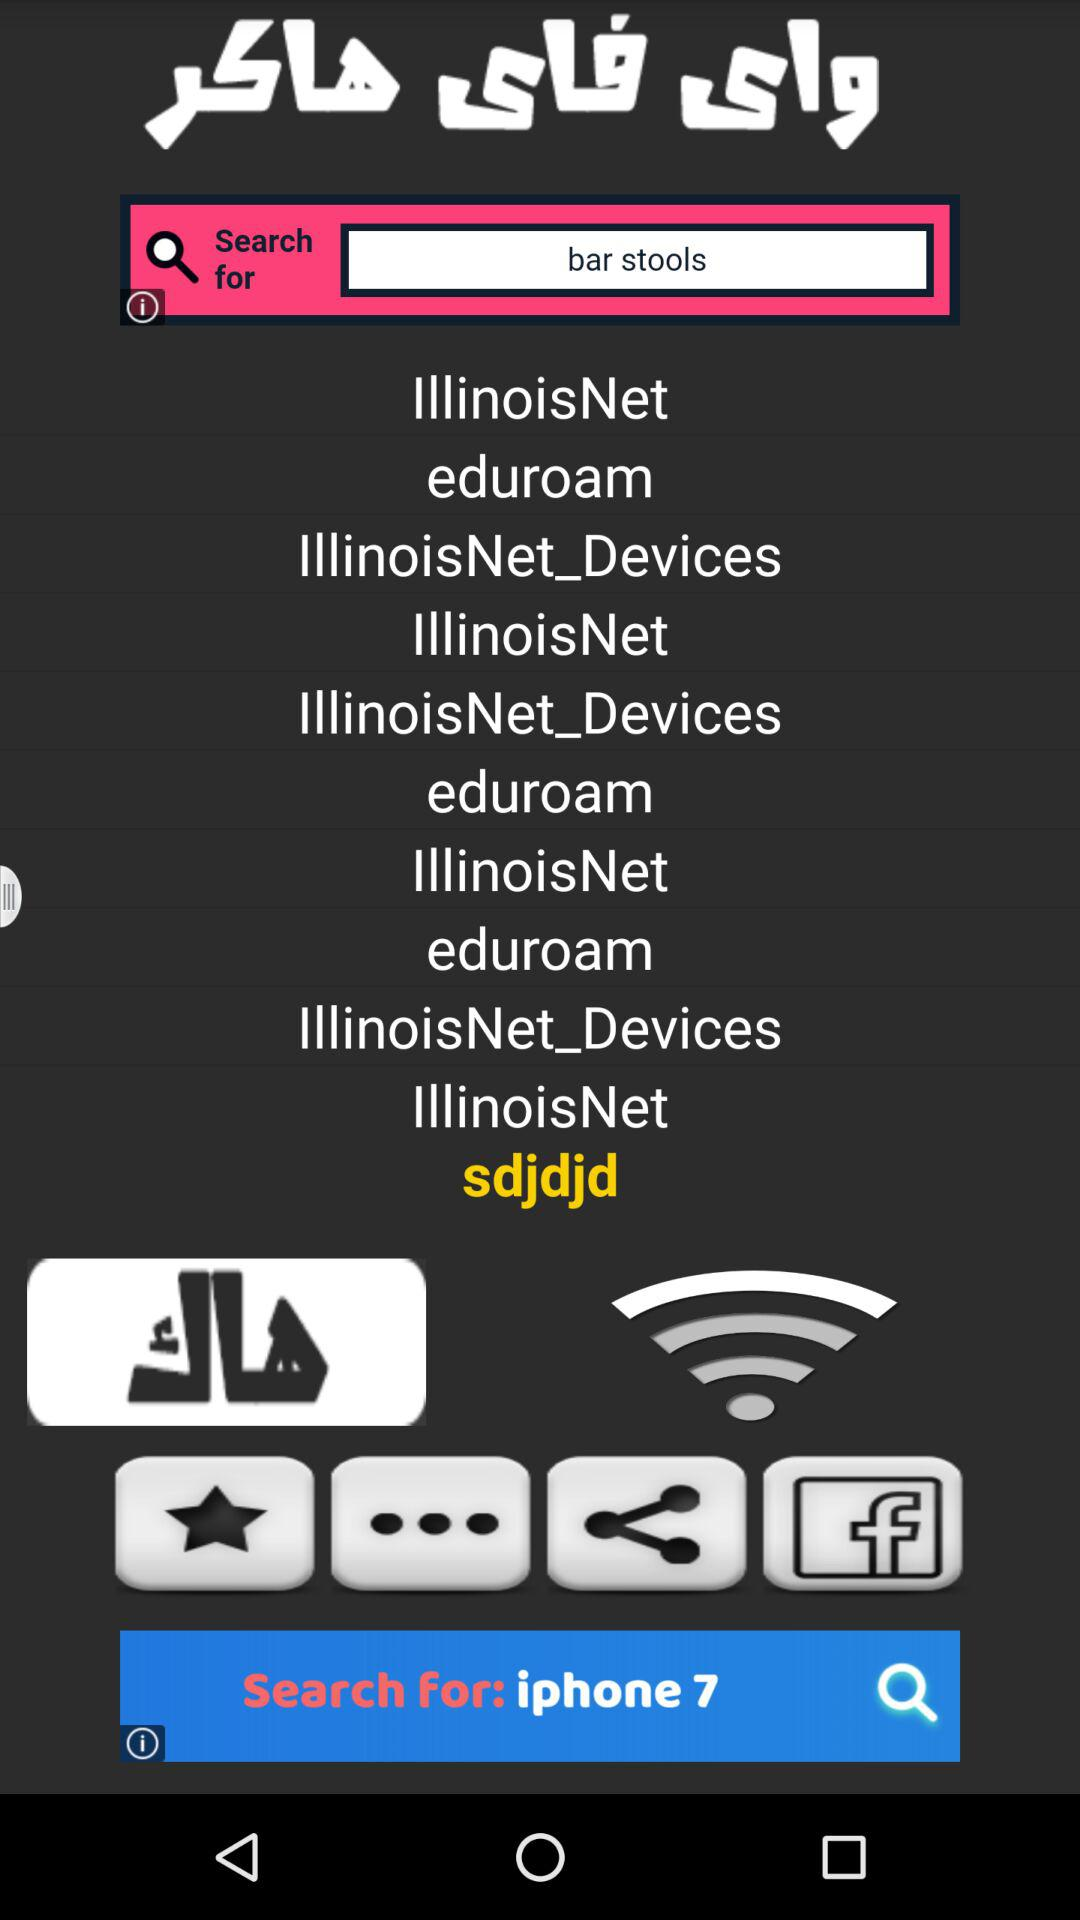Which WiFi network option is selected? The selected WiFi network option is "sdjdjd". 